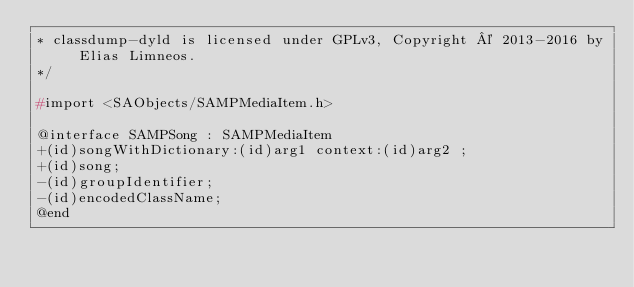Convert code to text. <code><loc_0><loc_0><loc_500><loc_500><_C_>* classdump-dyld is licensed under GPLv3, Copyright © 2013-2016 by Elias Limneos.
*/

#import <SAObjects/SAMPMediaItem.h>

@interface SAMPSong : SAMPMediaItem
+(id)songWithDictionary:(id)arg1 context:(id)arg2 ;
+(id)song;
-(id)groupIdentifier;
-(id)encodedClassName;
@end

</code> 